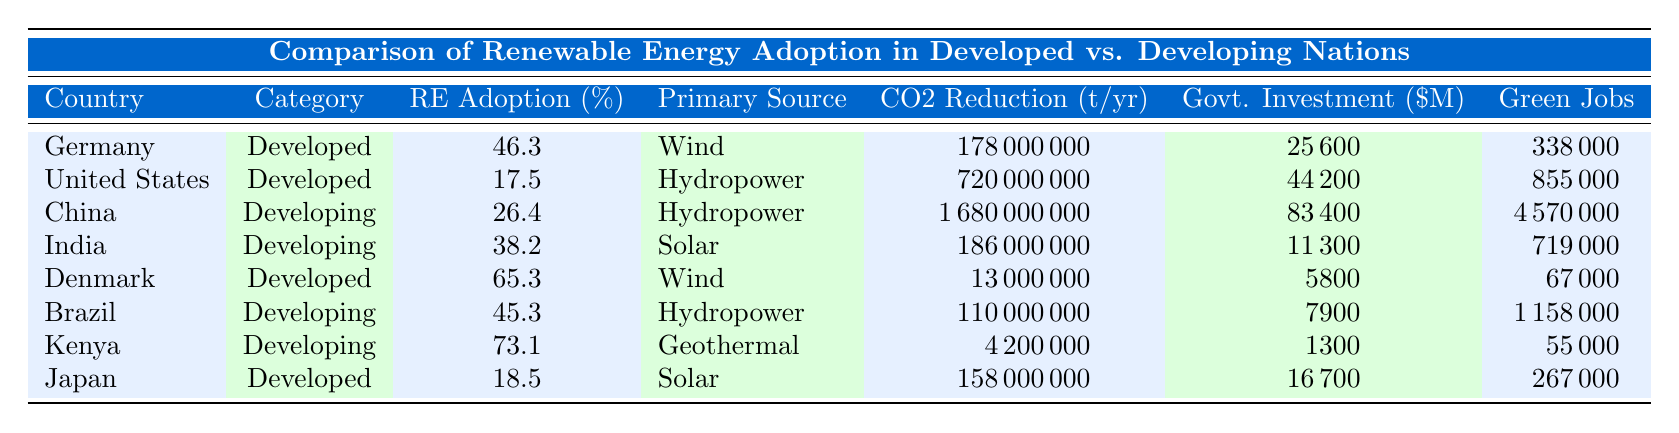What is the renewable energy adoption rate of Germany? The table shows that Germany has a renewable energy adoption rate of 46.3%.
Answer: 46.3% Which country has the highest number of green jobs created among the developed nations? By checking the 'Number of Green Jobs Created' column for developed nations, the United States has the highest number with 855,000 green jobs.
Answer: United States What is the primary renewable source for Kenya? The table indicates that the primary renewable source for Kenya is geothermal.
Answer: Geothermal What is the average renewable energy adoption rate for the developing nations listed? To find the average, add the rates of China (26.4), India (38.2), Brazil (45.3), and Kenya (73.1), which equals 183.0. Then, divide by 4 to find the average: 183.0 / 4 = 45.75%.
Answer: 45.75% Is it true that Japan has a higher renewable energy adoption rate than China? Yes, Japan's adoption rate is 18.5%, which is lower than China's rate of 26.4%. Therefore, the statement is false.
Answer: No What is the total CO2 emissions reduction achieved by Brazil and Kenya combined? Adding the CO2 emissions reductions of Brazil (110,000,000) and Kenya (4,200,000) gives a total of 114,200,000 metric tons/year.
Answer: 114200000 Which developed nation has the lowest government investment in renewable energy? By examining the 'Government Investment' column, Denmark has the lowest investment at 5,800 million USD.
Answer: Denmark Calculate the difference in renewable energy adoption rates between Denmark and Germany. Denmark’s rate is 65.3% and Germany’s rate is 46.3%. The difference is 65.3 - 46.3 = 19.0%.
Answer: 19.0% 